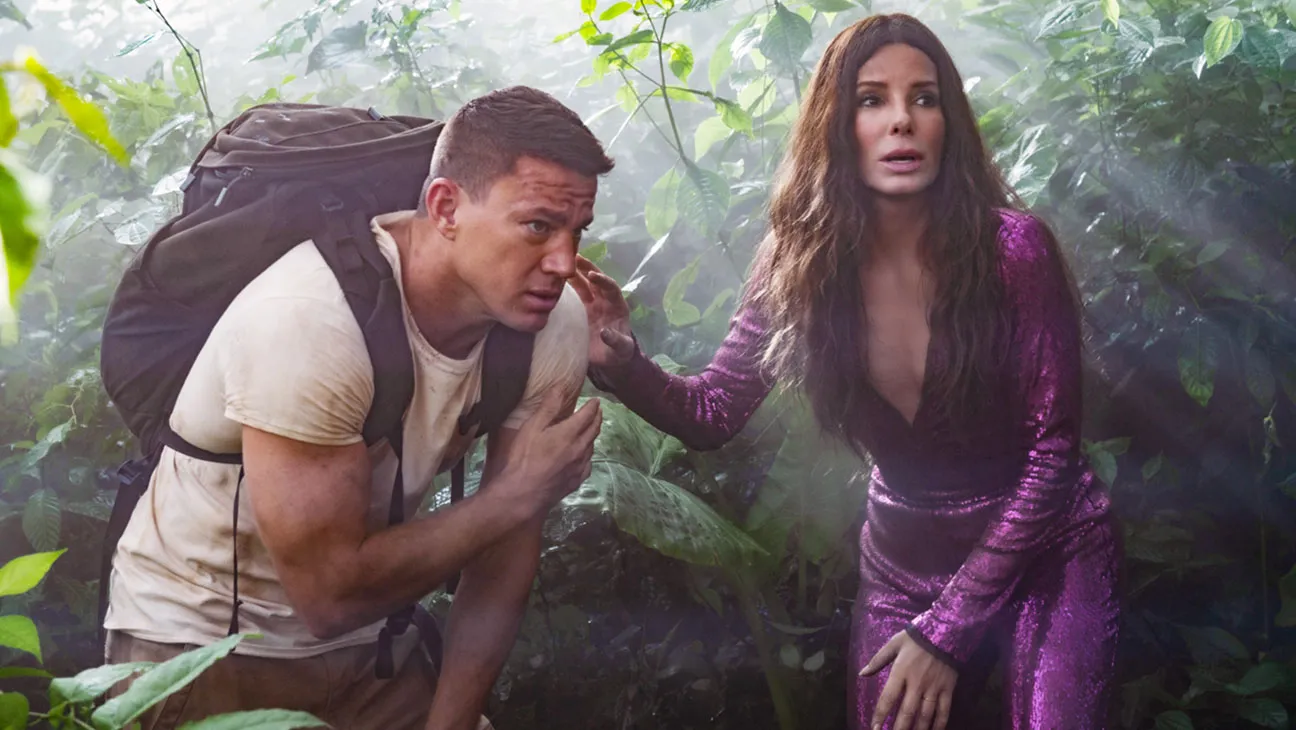What if this jungle is enchanted? If this jungle is enchanted, it would transform from a mere backdrop into a realm of magic and mystery. The foliage would shimmer with a supernatural glow, giving off an ethereal light. Every plant and tree could have a consciousness, whispering secrets of the forest or guiding our adventurers with gentle rustles and cryptic murmurs. Strange, mythical creatures might appear, watching from the shadows or playfully interacting with Bullock and Tatum. The air would be thick with enchantment, the very essence of magic lingering in every breath. Paths that seem non-existent might magically appear, and dangers could manifest in the form of enchanted traps or guardians. This jungle would be a living, breathing character, adding layers of intrigue and challenge to their quest. Can you describe a magical animal they might encounter? While trekking through the enchanted jungle, Sandra Bullock and Channing Tatum might encounter a serene creature known as a Lumigryph. This mythical beast has a body reminiscent of a large griffin, but its feathers and fur glisten with a bioluminescent glow, shifting colors with its mood. Its eyes are deep pools of understanding, capable of discerning the intentions of those it meets. The Lumigryph has the ability to communicate telepathically, sharing wisdom or warnings with our adventurers. Its presence is both regal and calming, and it may offer guidance through the trials of the enchanted jungle. Its calls are harmonious, resonating like a symphony through the forest, and its wings, when spread, create an aura that dispels darkness and malevolence from their path. What about a realistic scenario where they escape from a danger? Sandra Bullock and Channing Tatum find themselves on the run from a territorial jaguar in the dense jungle. The animal, camouflaged seamlessly with the underbrush, suddenly charges at them with ferocious speed. Reacting quickly, Tatum grabs Bullock's hand, and they sprint through the thick foliage, dodging vines and leaping over roots. The jaguar's roars echo behind them, growing closer. They stumble upon an ancient, partially collapsed stone structure and quickly squeeze through a narrow opening just as the jaguar's claws swipe at the entrance. Safe inside the dark, cool interior, they catch their breath, their hearts pounding from the chase. They realize that this might be an old temple, forgotten by time, and perhaps their refuge holds more secrets than they initially thought. 